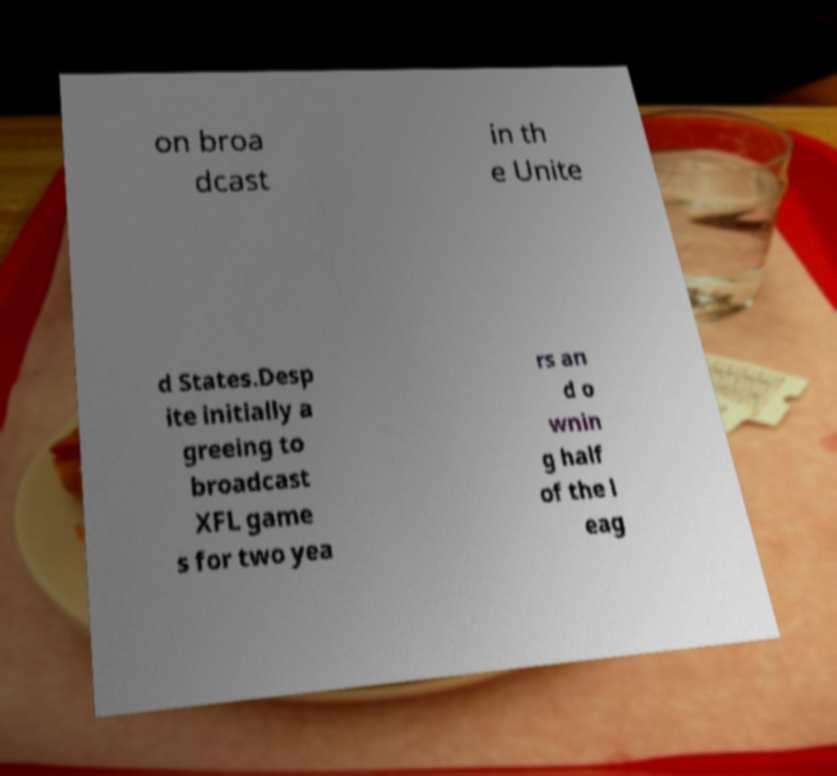Can you accurately transcribe the text from the provided image for me? on broa dcast in th e Unite d States.Desp ite initially a greeing to broadcast XFL game s for two yea rs an d o wnin g half of the l eag 